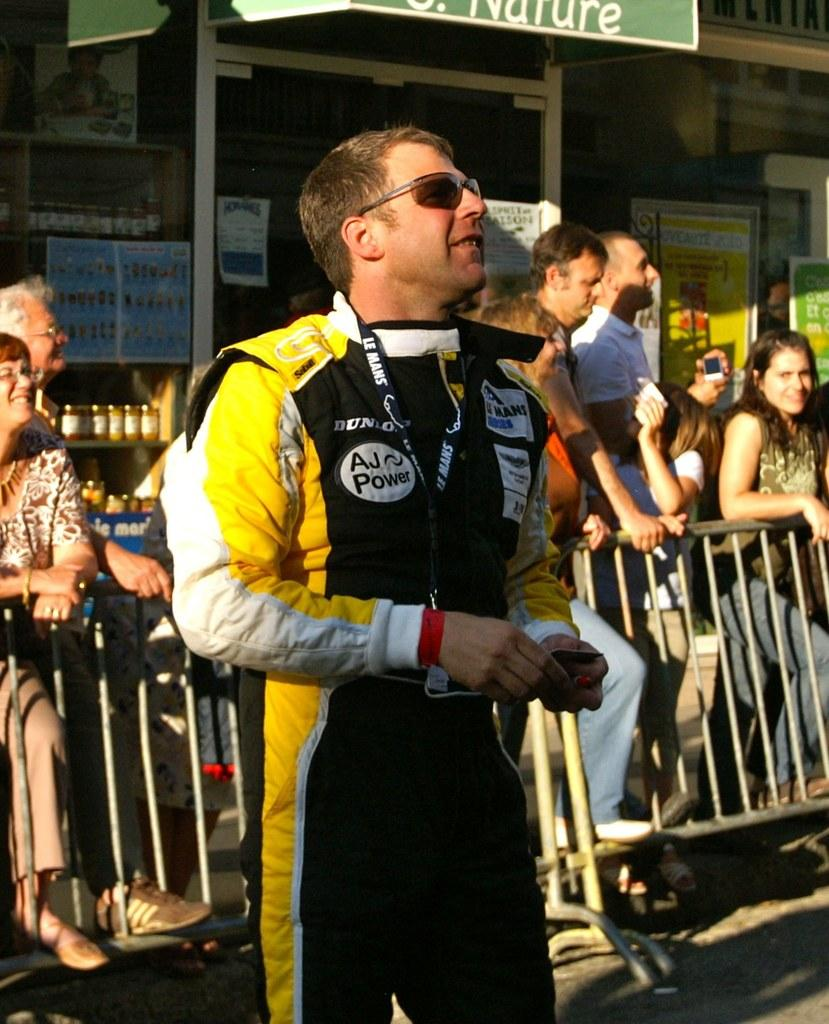What is the man in the image wearing? The man in the image is wearing a yellow and black jacket. How many people are standing behind the man? There are many people standing behind the man. What can be seen between the people and the building in the background? The people are standing in front of a fence. What type of structure can be seen in the background of the image? There is a building visible in the background of the image. What type of fish can be seen swimming in the oven in the image? There is no oven or fish present in the image. 